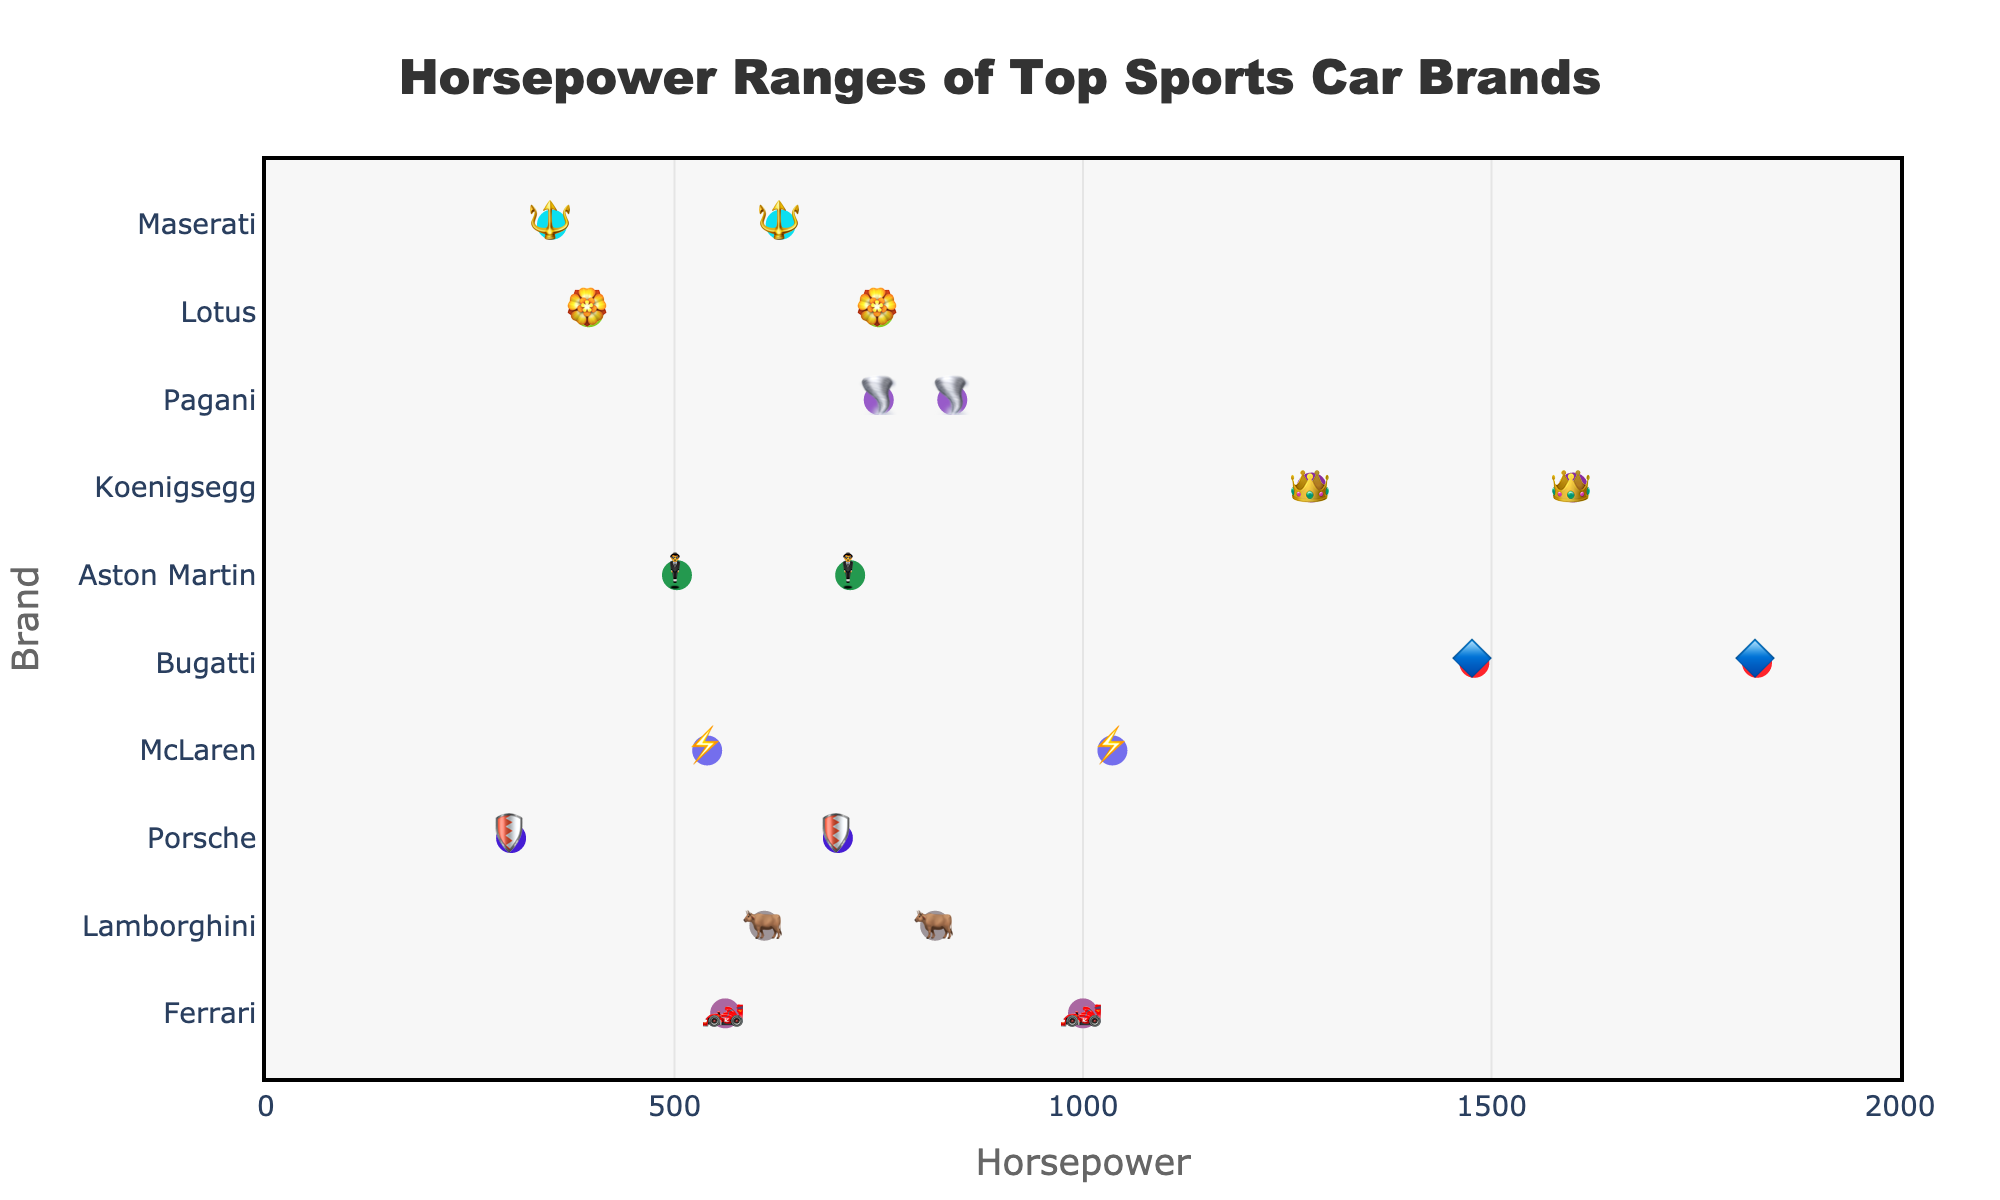What's the title of the figure? The title is located at the top of the figure. It appears prominently in a bigger and bolder font.
Answer: Horsepower Ranges of Top Sports Car Brands Which sports car brand has the largest range of horsepower? By examining the range values, Bugatti has the maximum horsepower of 1825 and a minimum of 1479, resulting in the largest range.
Answer: Bugatti What is the minimum and maximum horsepower for Ferrari? Locate Ferrari's data points on the horizontal axis. The values span from 562 to 1000.
Answer: 562 and 1000 Which brand has the highest minimum horsepower? Look at the leftmost data points of each brand. Bugatti shows the highest minimum horsepower at 1479.
Answer: Bugatti How many brands have a maximum horsepower greater than 1000? Count the brands with a maximum horsepower above 1000. McLaren, Bugatti, and Koenigsegg fit this criterion.
Answer: 3 Which brand has the smallest range of horsepower? Compare the difference between maximum and minimum horsepower for each brand. Maserati's range is 280 (630-350), which is the smallest.
Answer: Maserati What is the average maximum horsepower for Porsche, Lotus, and Aston Martin? Find the maximum horsepower for each brand, add them (700+750+715=2165), then divide by 3 (2165/3).
Answer: 721.67 What is the highest horsepower value in the entire dataset? Look for the highest maximum horsepower among all brands. Bugatti has the top value at 1825.
Answer: 1825 Which brands have their maximum horsepower between 800 and 900? Identify brands with maximum horsepower within this interval. Lamborghini and Pagani qualify.
Answer: Lamborghini and Pagani How does Lamborghini's horsepower range compare to that of Koenigsegg? Compare both the minimum and maximum horsepower values. Lamborghini ranges from 610 to 819, while Koenigsegg ranges from 1280 to 1600.
Answer: Lamborghini has a smaller horsepower range than Koenigsegg 